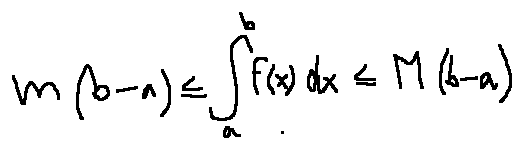<formula> <loc_0><loc_0><loc_500><loc_500>m ( b - a ) \leq \int \lim i t s _ { a } ^ { b } f ( x ) d x \leq M ( b - a )</formula> 